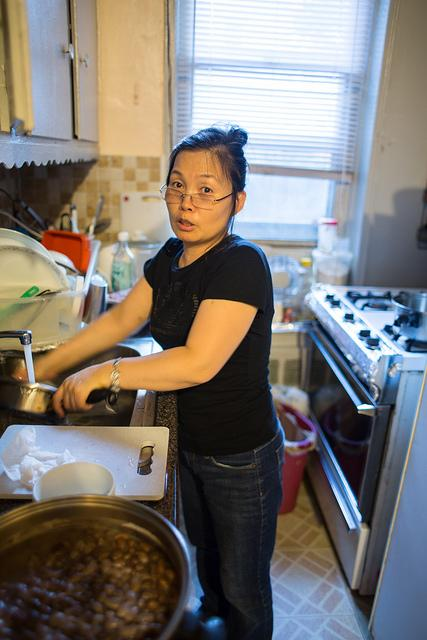What chore does the woman perform?

Choices:
A) dusting
B) basting
C) dish washing
D) frying dish washing 